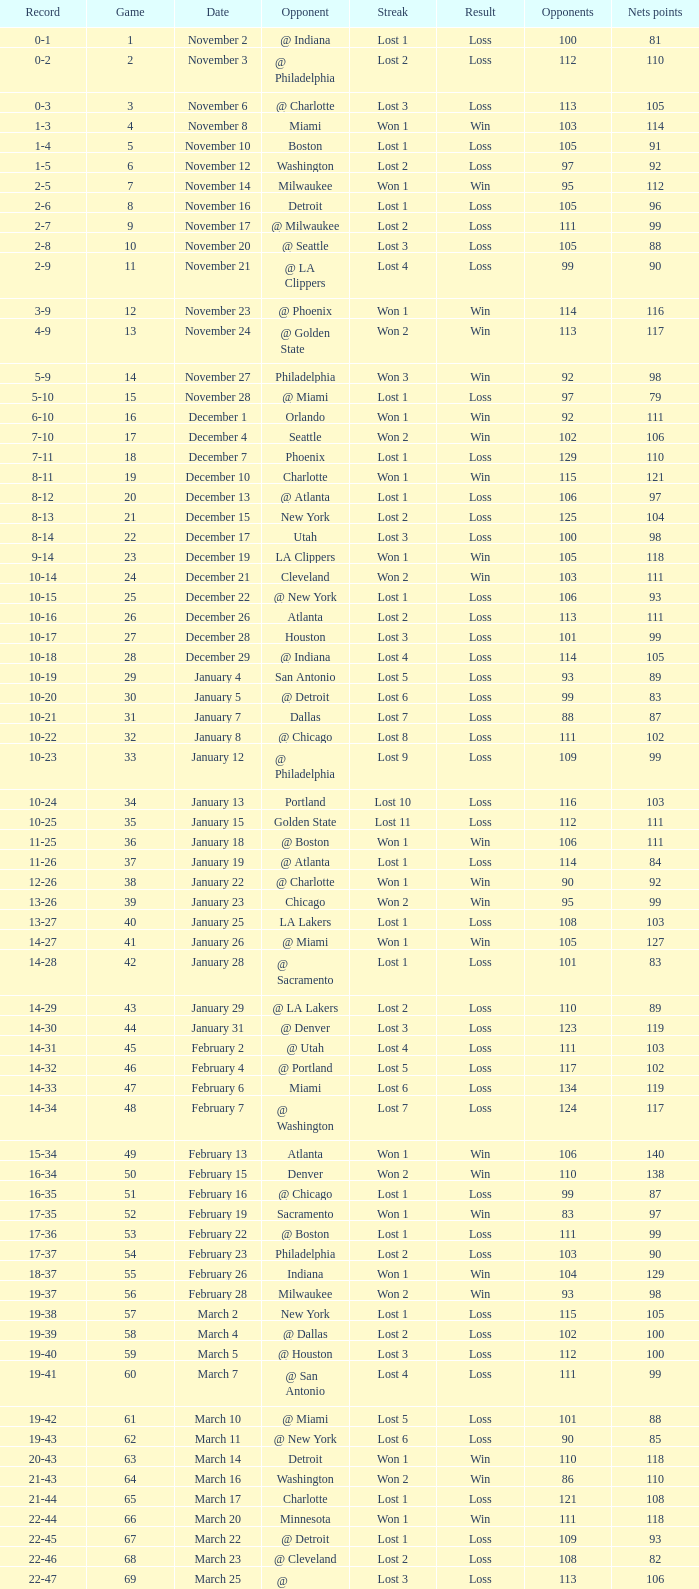In which game did the opponent score more than 103 and the record was 1-3? None. 